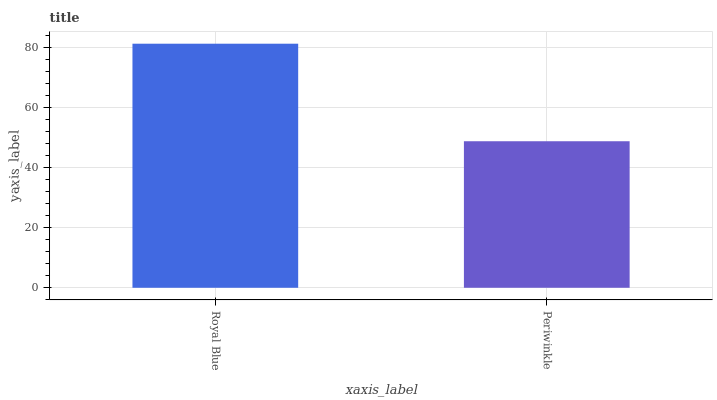Is Periwinkle the minimum?
Answer yes or no. Yes. Is Royal Blue the maximum?
Answer yes or no. Yes. Is Periwinkle the maximum?
Answer yes or no. No. Is Royal Blue greater than Periwinkle?
Answer yes or no. Yes. Is Periwinkle less than Royal Blue?
Answer yes or no. Yes. Is Periwinkle greater than Royal Blue?
Answer yes or no. No. Is Royal Blue less than Periwinkle?
Answer yes or no. No. Is Royal Blue the high median?
Answer yes or no. Yes. Is Periwinkle the low median?
Answer yes or no. Yes. Is Periwinkle the high median?
Answer yes or no. No. Is Royal Blue the low median?
Answer yes or no. No. 